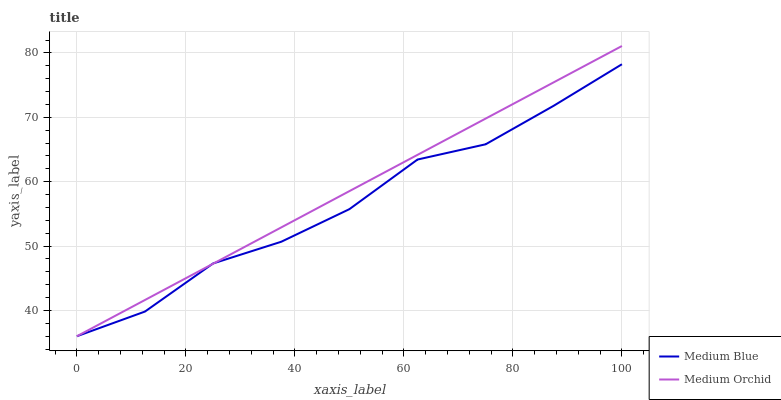Does Medium Blue have the minimum area under the curve?
Answer yes or no. Yes. Does Medium Orchid have the maximum area under the curve?
Answer yes or no. Yes. Does Medium Blue have the maximum area under the curve?
Answer yes or no. No. Is Medium Orchid the smoothest?
Answer yes or no. Yes. Is Medium Blue the roughest?
Answer yes or no. Yes. Is Medium Blue the smoothest?
Answer yes or no. No. Does Medium Orchid have the lowest value?
Answer yes or no. Yes. Does Medium Orchid have the highest value?
Answer yes or no. Yes. Does Medium Blue have the highest value?
Answer yes or no. No. Does Medium Blue intersect Medium Orchid?
Answer yes or no. Yes. Is Medium Blue less than Medium Orchid?
Answer yes or no. No. Is Medium Blue greater than Medium Orchid?
Answer yes or no. No. 